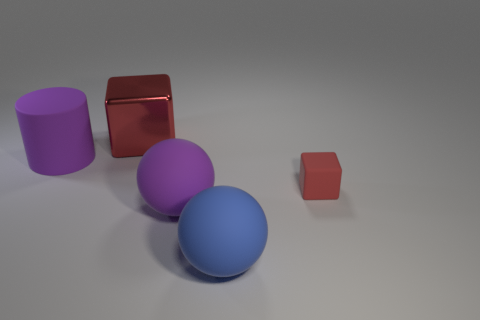Add 3 purple matte balls. How many objects exist? 8 Subtract all balls. How many objects are left? 3 Subtract 1 balls. How many balls are left? 1 Add 1 matte spheres. How many matte spheres exist? 3 Subtract 0 green blocks. How many objects are left? 5 Subtract all red rubber cubes. Subtract all brown objects. How many objects are left? 4 Add 4 small objects. How many small objects are left? 5 